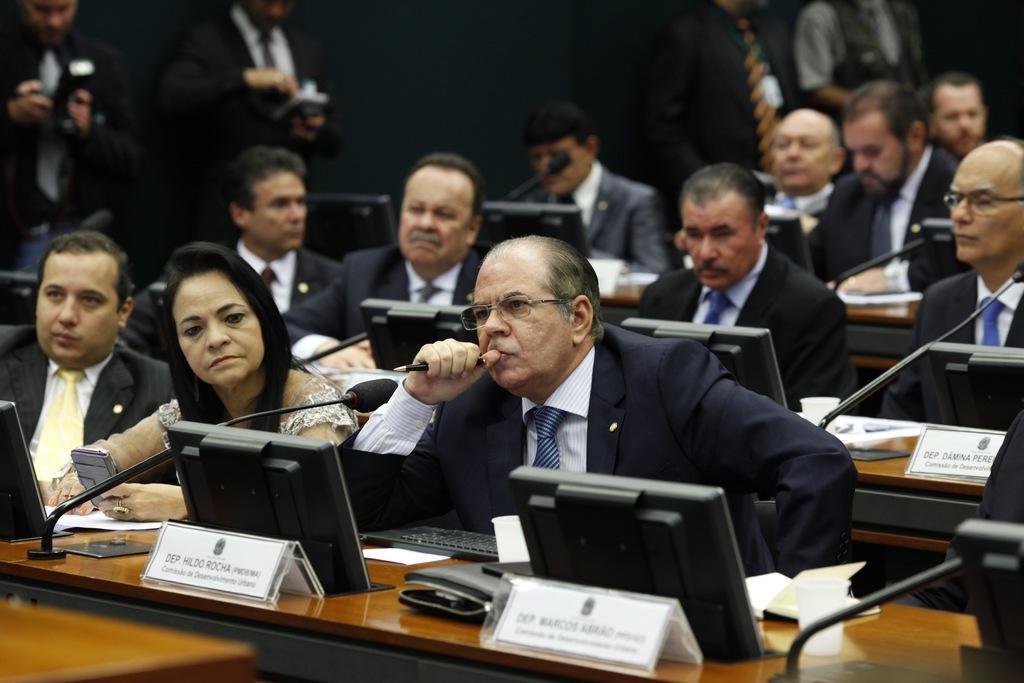Can you describe this image briefly? In this image I can see number of persons wearing black colored blazers and white colored shirts are sitting on chairs in front of the brown colored desks and on the desks I can see few screens, few white colored boards, few papers, few microphones and few other objects. In the background I can see few persons standing. 